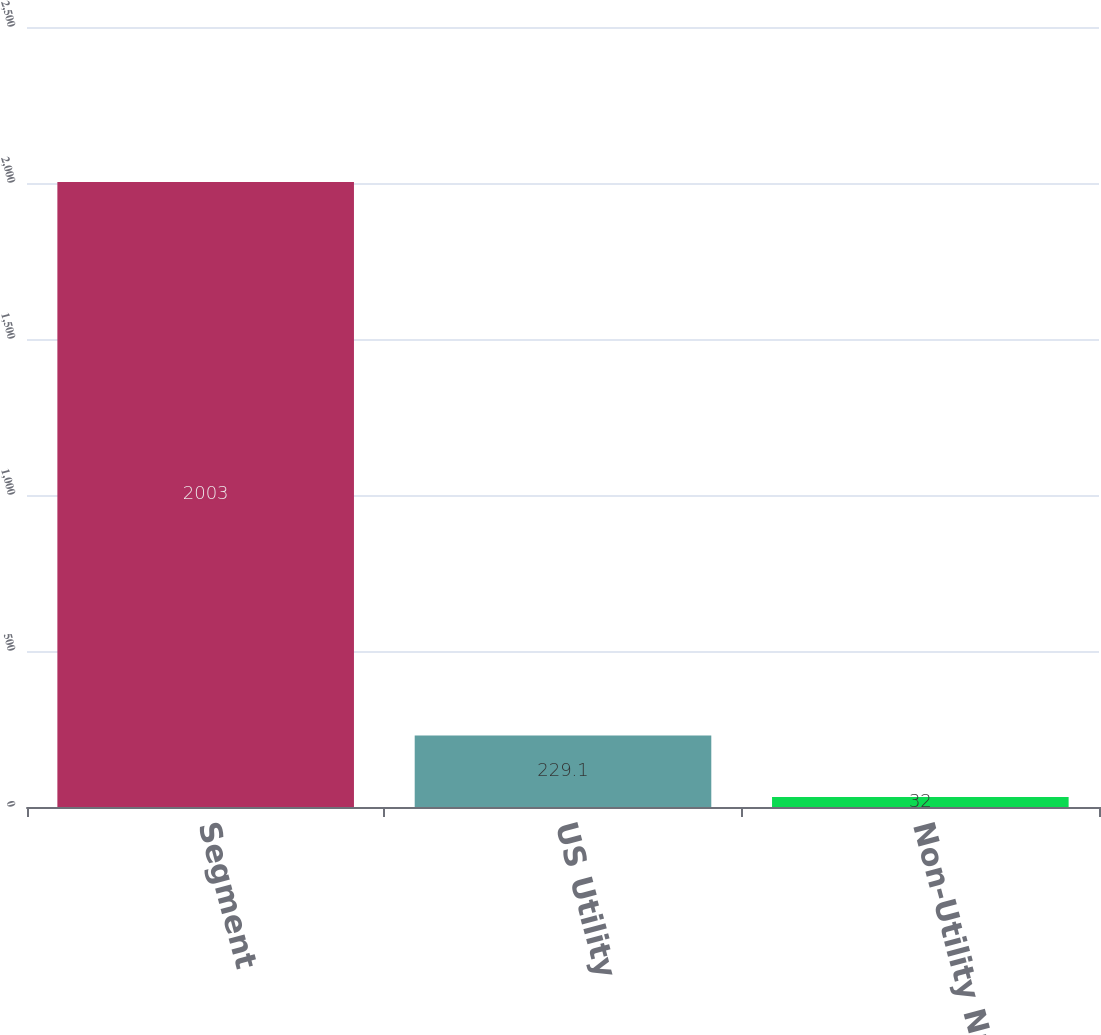Convert chart to OTSL. <chart><loc_0><loc_0><loc_500><loc_500><bar_chart><fcel>Segment<fcel>US Utility<fcel>Non-Utility Nuclear<nl><fcel>2003<fcel>229.1<fcel>32<nl></chart> 